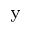<formula> <loc_0><loc_0><loc_500><loc_500>_ { y }</formula> 